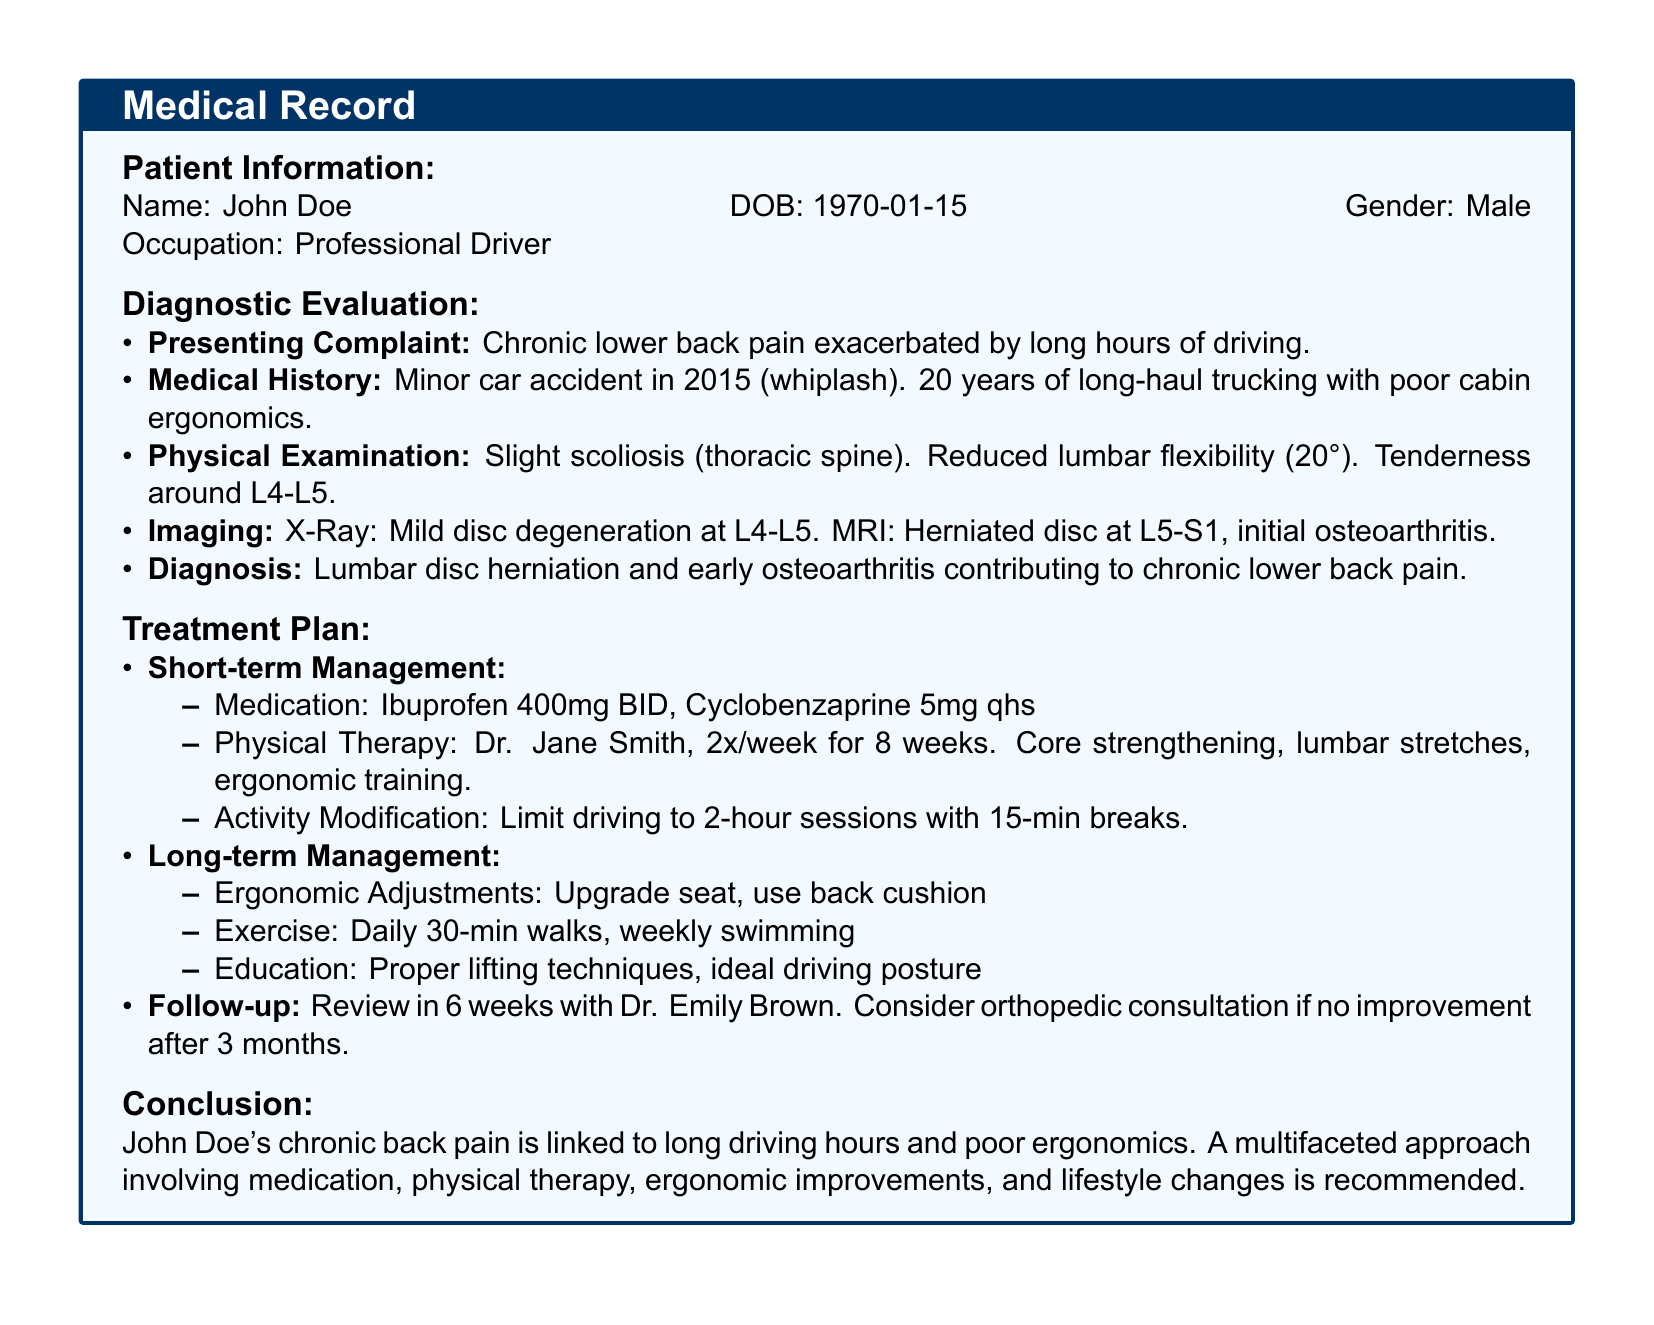What is the patient's name? The patient's name is clearly stated in the patient information section of the document.
Answer: John Doe What is the diagnosis? The diagnosis is found under the diagnostic evaluation section and summarizes the patient's condition.
Answer: Lumbar disc herniation and early osteoarthritis How many years has the patient been a driver? The document specifies the duration of the patient's driving career in the medical history section.
Answer: 20 years How often is physical therapy recommended? The treatment plan explicitly mentions the frequency of therapy sessions for the patient.
Answer: 2x/week What medication is prescribed for pain relief? The treatment plan lists medications prescribed for the patient's condition.
Answer: Ibuprofen 400mg BID What ergonomic adjustments are suggested? The treatment plan includes specific adjustments to help alleviate pain related to driving.
Answer: Upgrade seat, use back cushion When is the follow-up appointment scheduled? The follow-up details are clearly mentioned in the treatment plan section of the document.
Answer: 6 weeks What type of exercise is recommended? The treatment plan suggests activities to enhance the patient's fitness and well-being.
Answer: Daily 30-min walks What significant event is noted in the patient's medical history? The medical history section highlights any relevant events that could impact the patient's health condition.
Answer: Minor car accident in 2015 